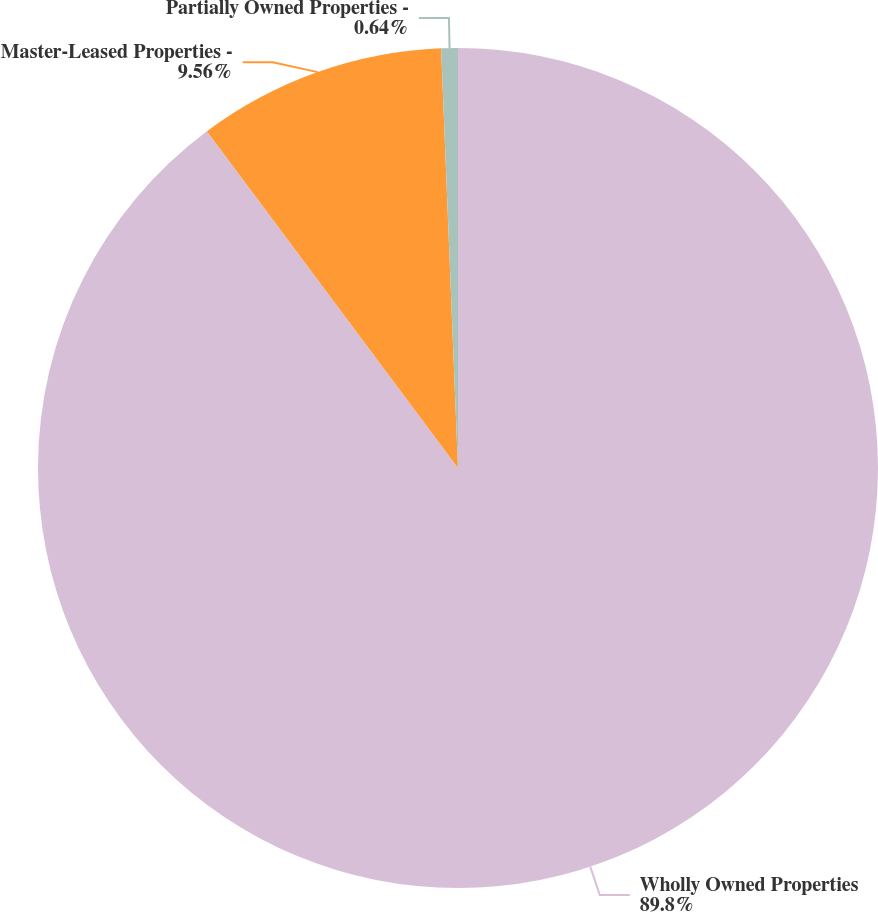<chart> <loc_0><loc_0><loc_500><loc_500><pie_chart><fcel>Wholly Owned Properties<fcel>Master-Leased Properties -<fcel>Partially Owned Properties -<nl><fcel>89.8%<fcel>9.56%<fcel>0.64%<nl></chart> 